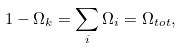<formula> <loc_0><loc_0><loc_500><loc_500>1 - \Omega _ { k } = \sum _ { i } \Omega _ { i } = \Omega _ { t o t } ,</formula> 